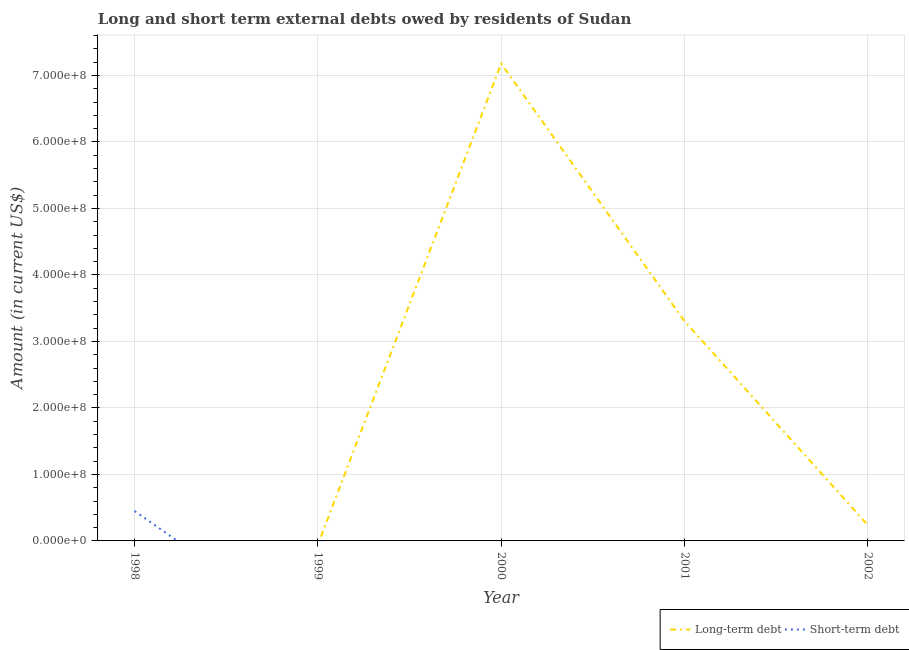Does the line corresponding to short-term debts owed by residents intersect with the line corresponding to long-term debts owed by residents?
Offer a very short reply. Yes. What is the long-term debts owed by residents in 2002?
Ensure brevity in your answer.  2.38e+07. Across all years, what is the maximum long-term debts owed by residents?
Your answer should be very brief. 7.18e+08. What is the total long-term debts owed by residents in the graph?
Provide a succinct answer. 1.07e+09. What is the difference between the long-term debts owed by residents in 2000 and that in 2001?
Give a very brief answer. 3.87e+08. What is the difference between the long-term debts owed by residents in 1998 and the short-term debts owed by residents in 2002?
Offer a very short reply. 0. What is the average long-term debts owed by residents per year?
Offer a terse response. 2.14e+08. What is the ratio of the long-term debts owed by residents in 2000 to that in 2001?
Offer a terse response. 2.17. Is the long-term debts owed by residents in 2000 less than that in 2002?
Ensure brevity in your answer.  No. What is the difference between the highest and the second highest long-term debts owed by residents?
Give a very brief answer. 3.87e+08. What is the difference between the highest and the lowest short-term debts owed by residents?
Ensure brevity in your answer.  4.50e+07. In how many years, is the short-term debts owed by residents greater than the average short-term debts owed by residents taken over all years?
Offer a very short reply. 1. Does the long-term debts owed by residents monotonically increase over the years?
Ensure brevity in your answer.  No. Is the short-term debts owed by residents strictly greater than the long-term debts owed by residents over the years?
Your response must be concise. No. Is the short-term debts owed by residents strictly less than the long-term debts owed by residents over the years?
Ensure brevity in your answer.  No. How many years are there in the graph?
Your response must be concise. 5. Does the graph contain any zero values?
Give a very brief answer. Yes. Where does the legend appear in the graph?
Ensure brevity in your answer.  Bottom right. How are the legend labels stacked?
Your answer should be compact. Horizontal. What is the title of the graph?
Offer a very short reply. Long and short term external debts owed by residents of Sudan. What is the label or title of the Y-axis?
Your response must be concise. Amount (in current US$). What is the Amount (in current US$) in Short-term debt in 1998?
Your answer should be very brief. 4.50e+07. What is the Amount (in current US$) of Short-term debt in 1999?
Offer a terse response. 0. What is the Amount (in current US$) of Long-term debt in 2000?
Provide a succinct answer. 7.18e+08. What is the Amount (in current US$) in Short-term debt in 2000?
Offer a very short reply. 0. What is the Amount (in current US$) in Long-term debt in 2001?
Your answer should be compact. 3.31e+08. What is the Amount (in current US$) of Long-term debt in 2002?
Provide a short and direct response. 2.38e+07. Across all years, what is the maximum Amount (in current US$) of Long-term debt?
Provide a succinct answer. 7.18e+08. Across all years, what is the maximum Amount (in current US$) of Short-term debt?
Offer a terse response. 4.50e+07. Across all years, what is the minimum Amount (in current US$) of Short-term debt?
Ensure brevity in your answer.  0. What is the total Amount (in current US$) in Long-term debt in the graph?
Provide a short and direct response. 1.07e+09. What is the total Amount (in current US$) of Short-term debt in the graph?
Keep it short and to the point. 4.50e+07. What is the difference between the Amount (in current US$) of Long-term debt in 2000 and that in 2001?
Keep it short and to the point. 3.87e+08. What is the difference between the Amount (in current US$) of Long-term debt in 2000 and that in 2002?
Provide a succinct answer. 6.94e+08. What is the difference between the Amount (in current US$) in Long-term debt in 2001 and that in 2002?
Offer a very short reply. 3.07e+08. What is the average Amount (in current US$) in Long-term debt per year?
Your answer should be very brief. 2.14e+08. What is the average Amount (in current US$) in Short-term debt per year?
Provide a short and direct response. 9.00e+06. What is the ratio of the Amount (in current US$) in Long-term debt in 2000 to that in 2001?
Your answer should be very brief. 2.17. What is the ratio of the Amount (in current US$) in Long-term debt in 2000 to that in 2002?
Make the answer very short. 30.2. What is the ratio of the Amount (in current US$) of Long-term debt in 2001 to that in 2002?
Your answer should be compact. 13.91. What is the difference between the highest and the second highest Amount (in current US$) of Long-term debt?
Offer a very short reply. 3.87e+08. What is the difference between the highest and the lowest Amount (in current US$) of Long-term debt?
Give a very brief answer. 7.18e+08. What is the difference between the highest and the lowest Amount (in current US$) of Short-term debt?
Provide a succinct answer. 4.50e+07. 